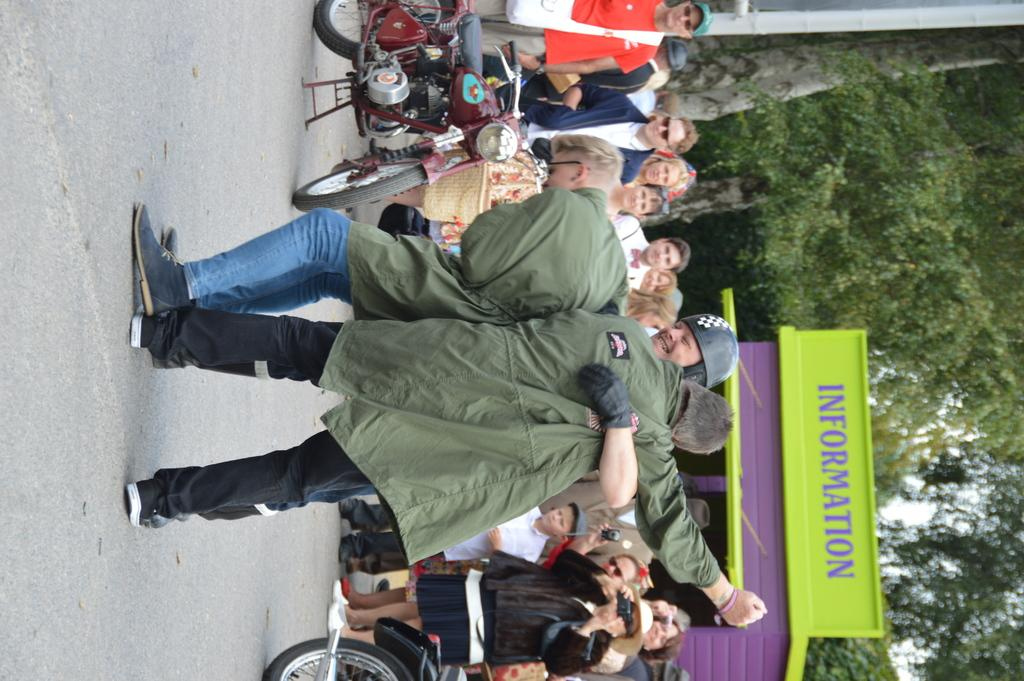What is happening on the road in the image? There are people performing on the road. Are there any spectators in the image? Yes, there are people standing and watching the performance. What type of treatment is being administered to the plants in the image? There are no plants present in the image, so no treatment is being administered. What error can be seen in the performance in the image? There is no indication of an error in the performance in the image. 